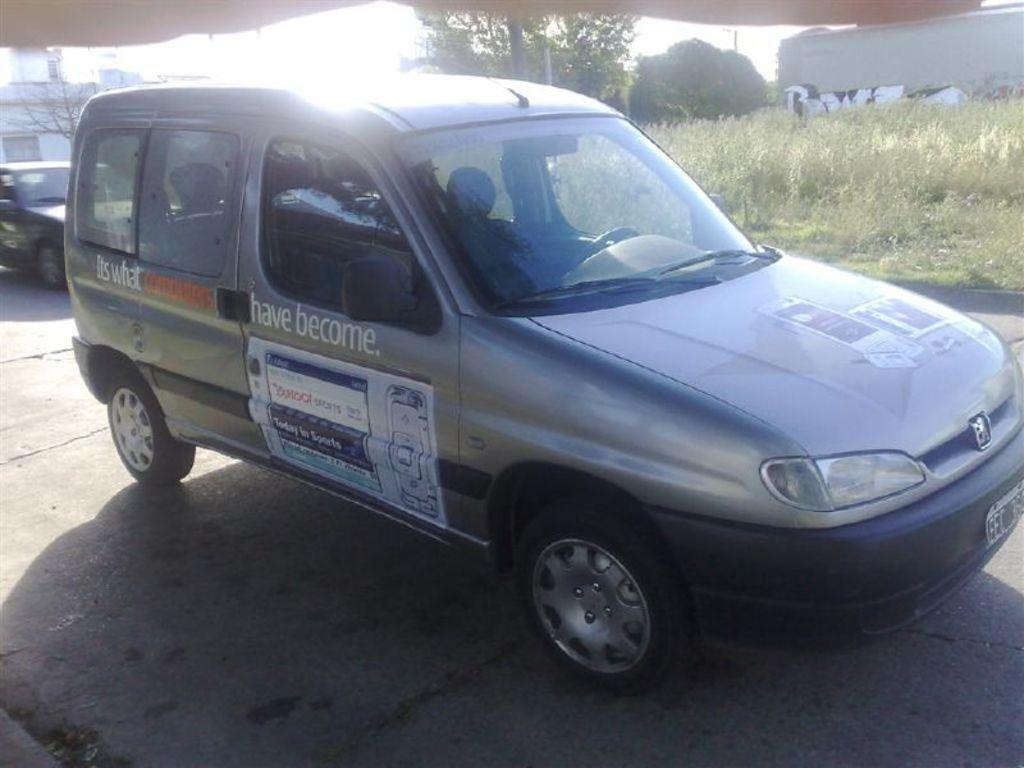<image>
Offer a succinct explanation of the picture presented. a vehicle with the words have become on it 